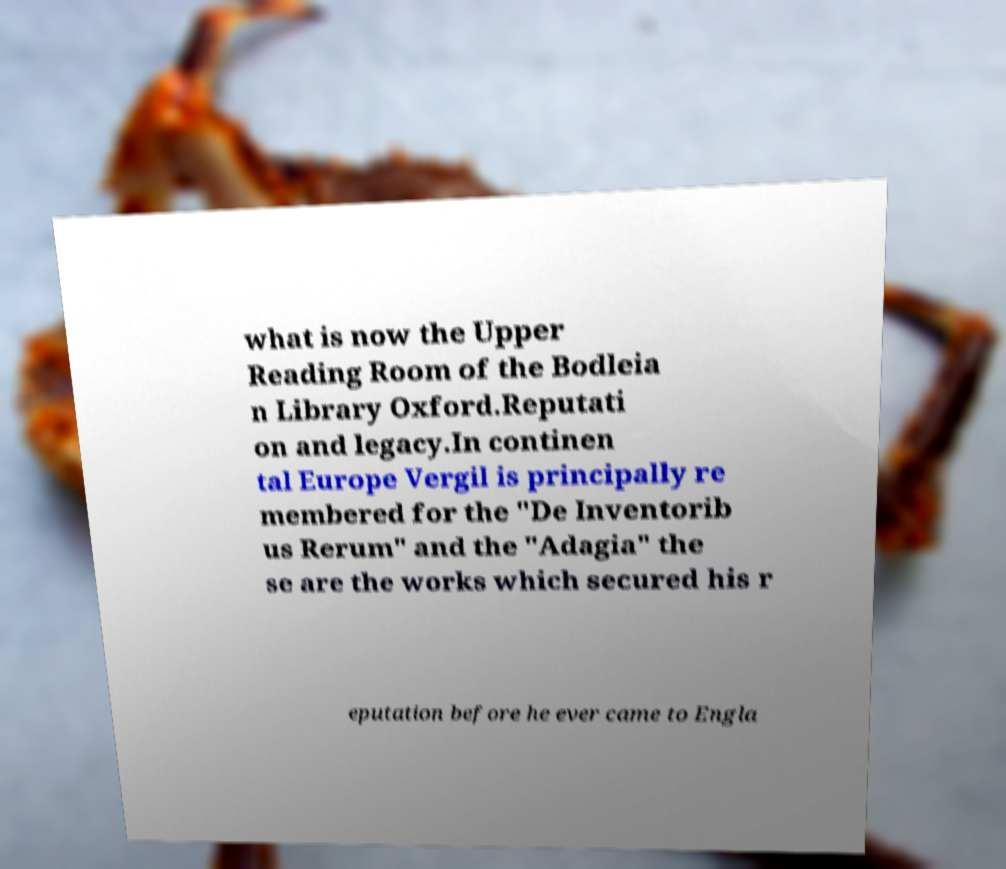Please read and relay the text visible in this image. What does it say? what is now the Upper Reading Room of the Bodleia n Library Oxford.Reputati on and legacy.In continen tal Europe Vergil is principally re membered for the "De Inventorib us Rerum" and the "Adagia" the se are the works which secured his r eputation before he ever came to Engla 